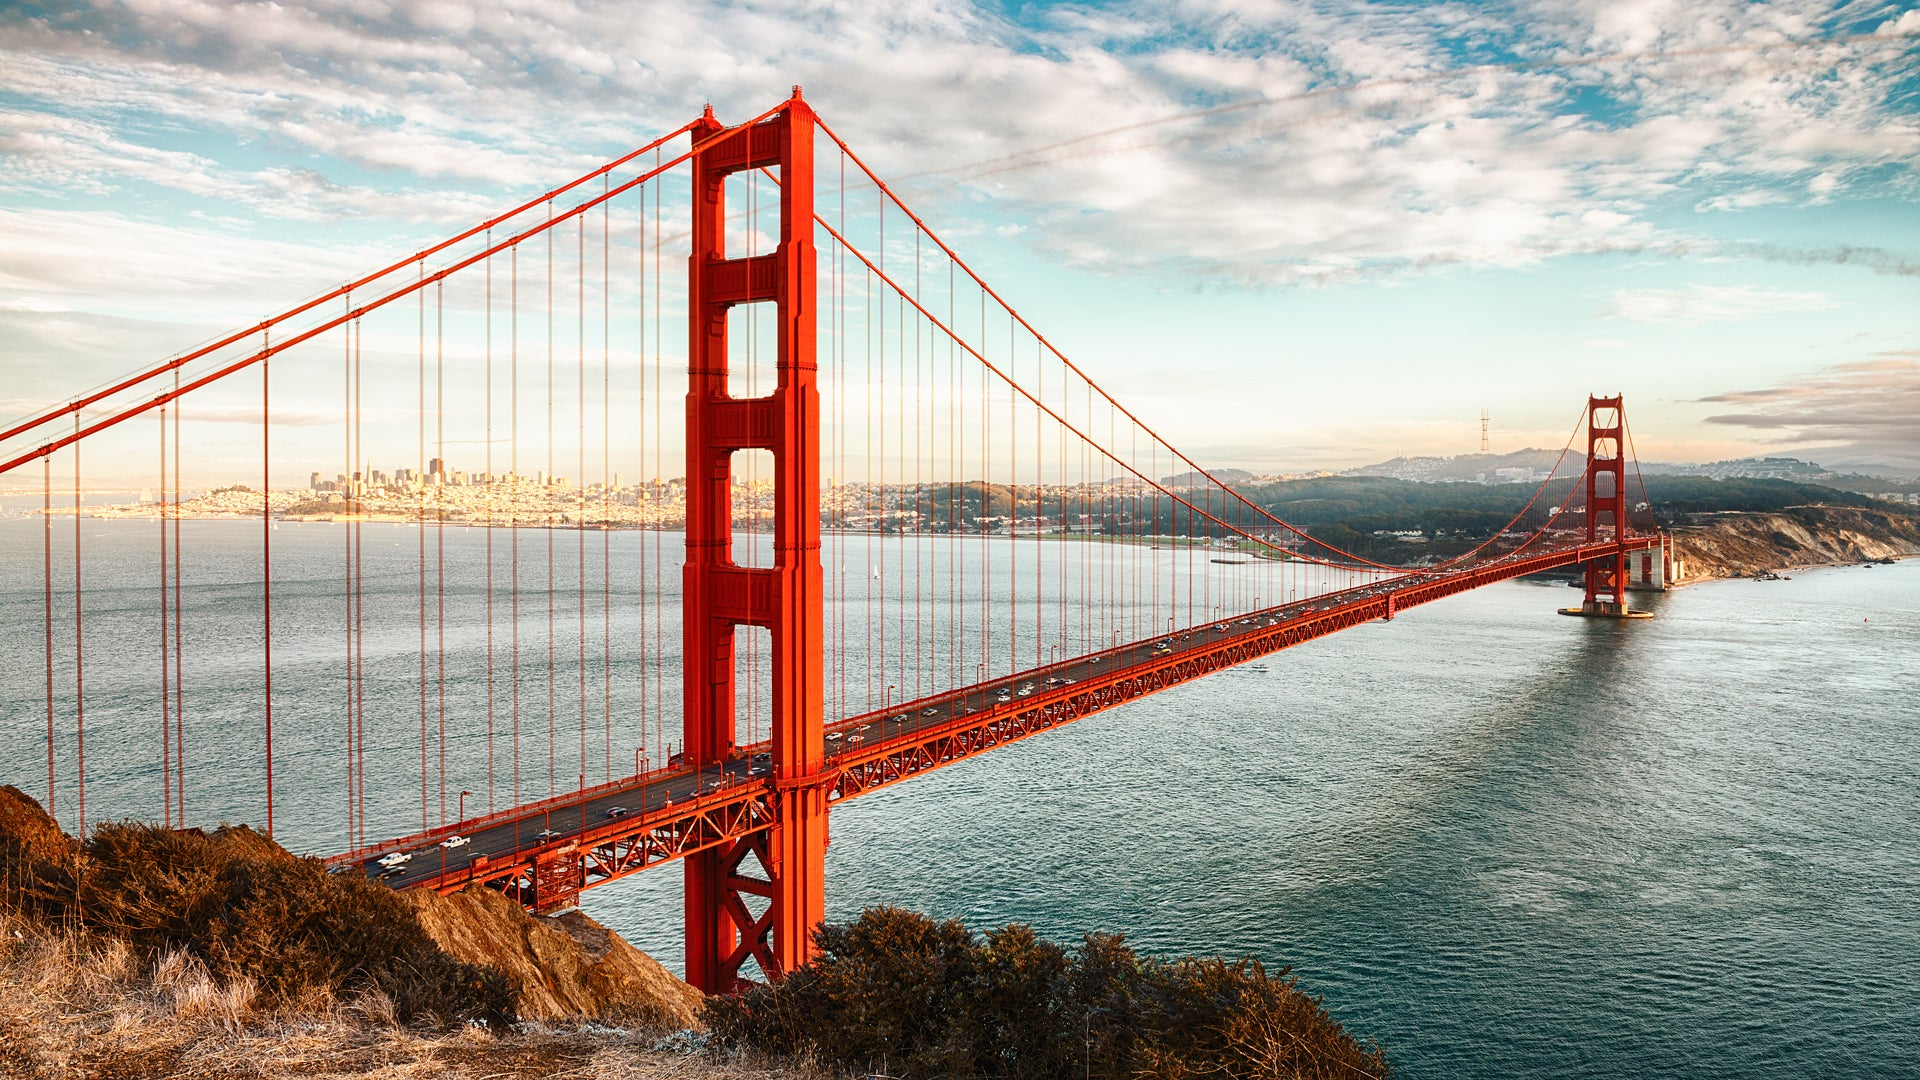What might be happening on the bridge at the time this photo was taken? Given the constant flow of traffic on the Golden Gate Bridge, there are likely numerous vehicles crossing at the time this photo was taken. You might find a mix of commuters heading to and from work, tourists admiring the bridge and the views it offers, and perhaps even some pedestrians and cyclists enjoying a walk or ride on the pathways flanking the roadway. The serene backdrop suggests it's a pleasant day, encouraging people to take their time and take in the sights. 